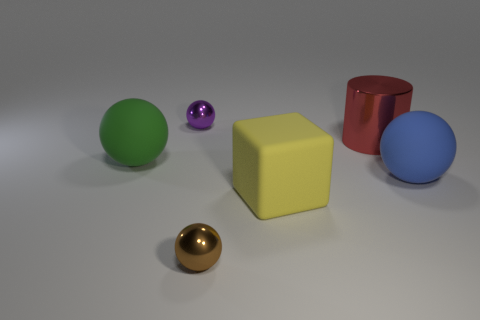Which objects in this image are capable of rolling? The green, blue, purple, and golden spheres are all capable of rolling due to their perfectly round shape. The yellow rubber cube and the red cylinder would not roll under normal circumstances, as the cube is a solid six-faced object and the cylinder will only roll if tipped onto its curved surface. 